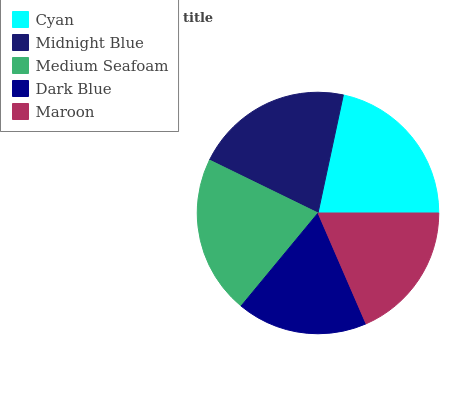Is Dark Blue the minimum?
Answer yes or no. Yes. Is Cyan the maximum?
Answer yes or no. Yes. Is Midnight Blue the minimum?
Answer yes or no. No. Is Midnight Blue the maximum?
Answer yes or no. No. Is Cyan greater than Midnight Blue?
Answer yes or no. Yes. Is Midnight Blue less than Cyan?
Answer yes or no. Yes. Is Midnight Blue greater than Cyan?
Answer yes or no. No. Is Cyan less than Midnight Blue?
Answer yes or no. No. Is Midnight Blue the high median?
Answer yes or no. Yes. Is Midnight Blue the low median?
Answer yes or no. Yes. Is Cyan the high median?
Answer yes or no. No. Is Dark Blue the low median?
Answer yes or no. No. 